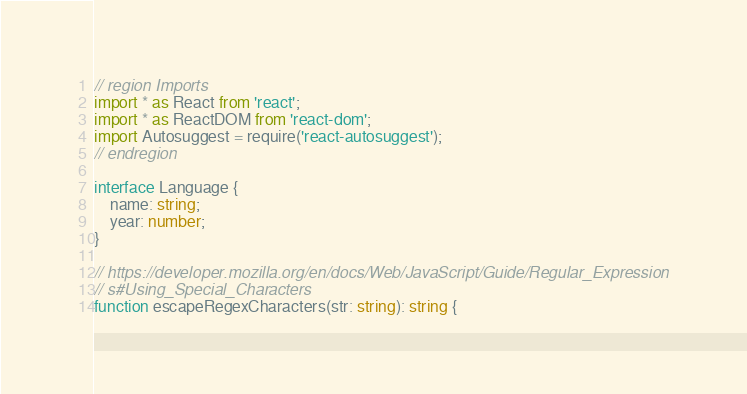Convert code to text. <code><loc_0><loc_0><loc_500><loc_500><_TypeScript_>// region Imports
import * as React from 'react';
import * as ReactDOM from 'react-dom';
import Autosuggest = require('react-autosuggest');
// endregion

interface Language {
    name: string;
    year: number;
}

// https://developer.mozilla.org/en/docs/Web/JavaScript/Guide/Regular_Expression
// s#Using_Special_Characters
function escapeRegexCharacters(str: string): string {</code> 